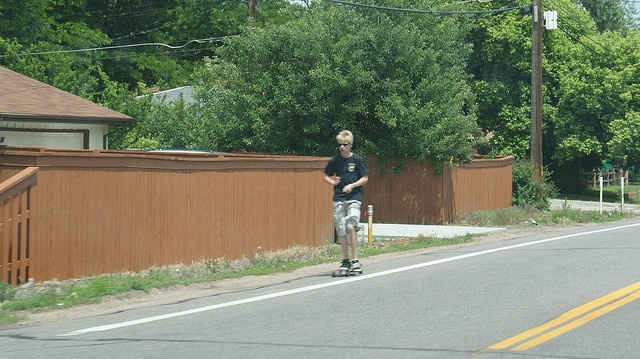Describe the objects in this image and their specific colors. I can see people in darkgreen, darkgray, black, gray, and purple tones and skateboard in darkgreen, darkgray, gray, ivory, and black tones in this image. 